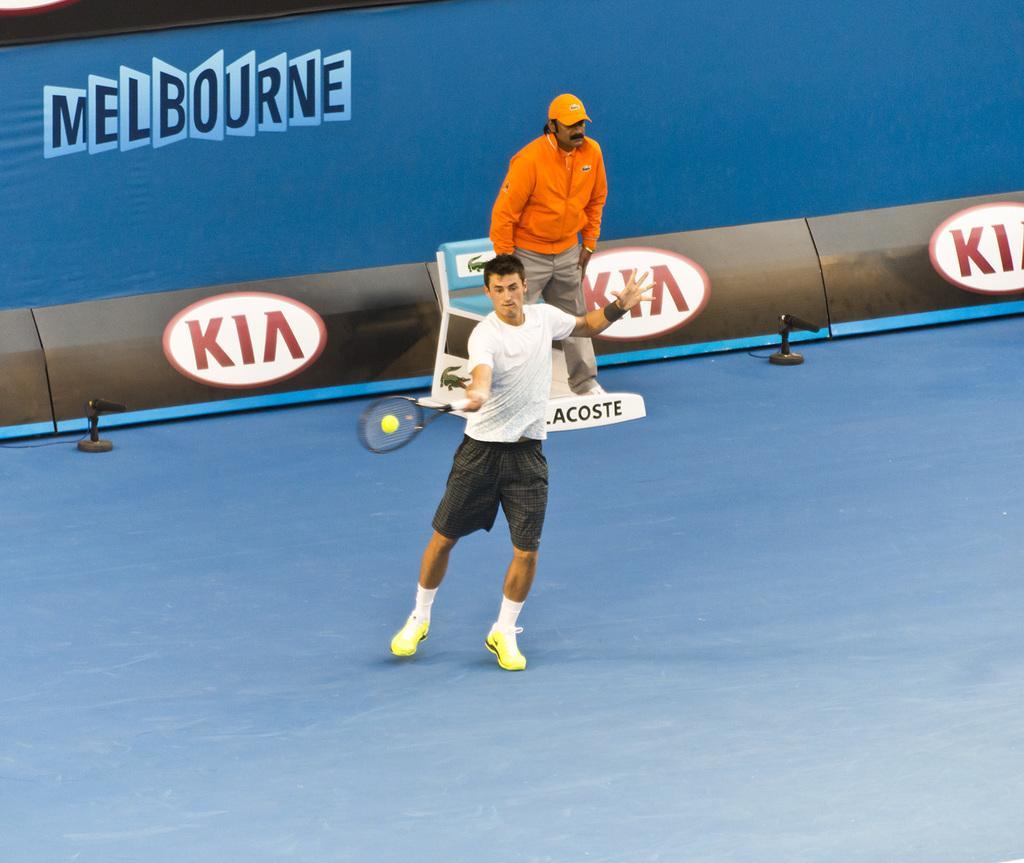Could you give a brief overview of what you see in this image? This 2 persons are standing. This person is holding a bat and trying to hit a ball. This are banners. 